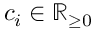<formula> <loc_0><loc_0><loc_500><loc_500>c _ { i } \in { \mathbb { R } } _ { \geq 0 }</formula> 